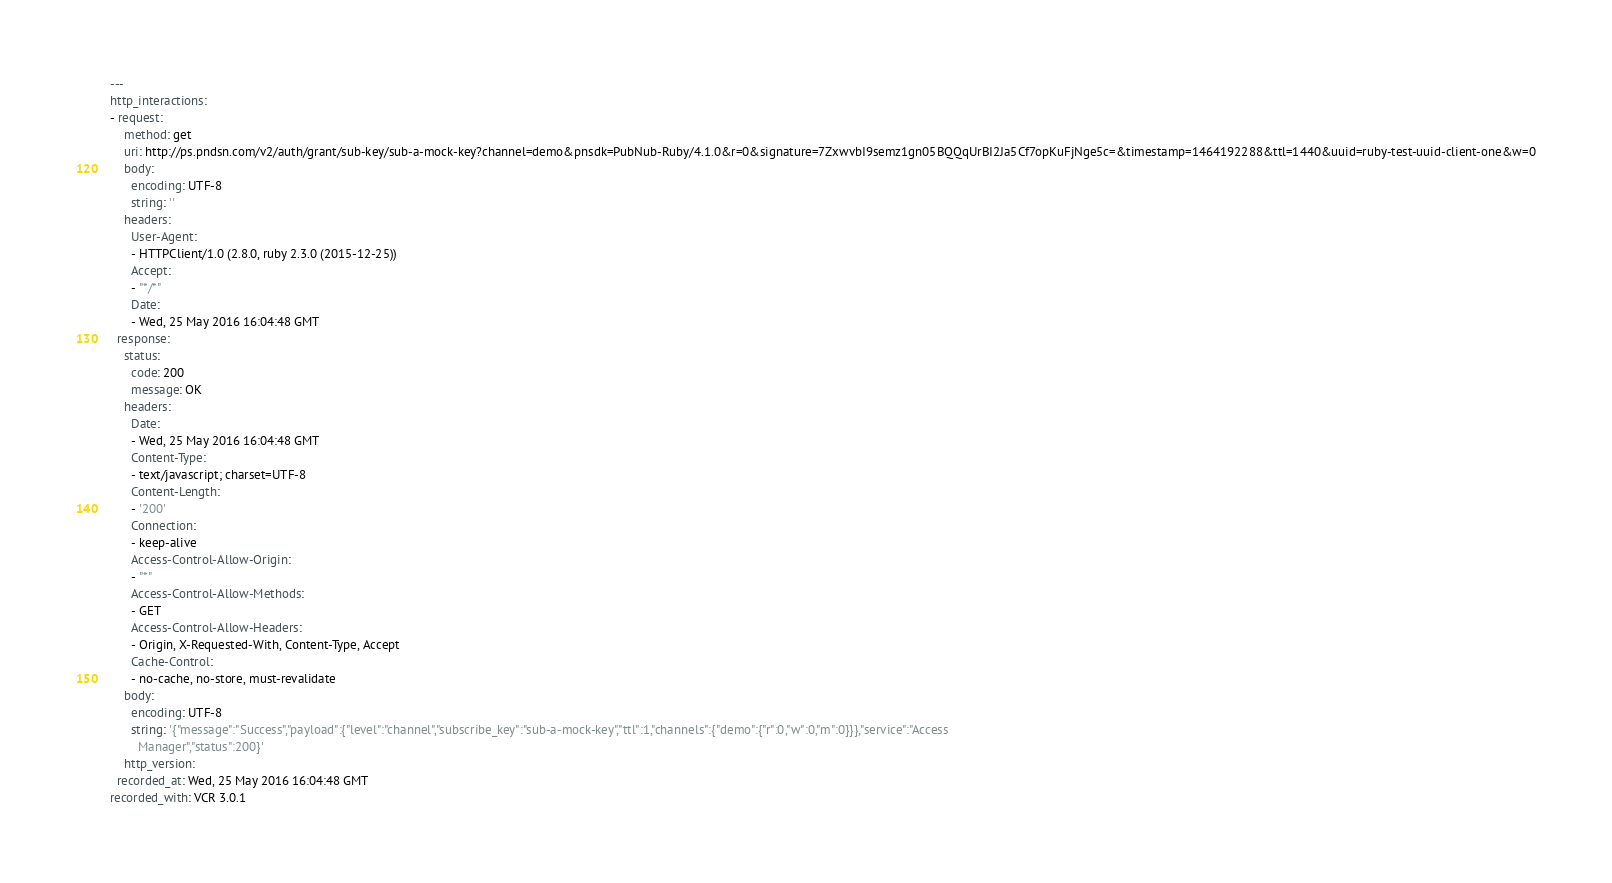Convert code to text. <code><loc_0><loc_0><loc_500><loc_500><_YAML_>---
http_interactions:
- request:
    method: get
    uri: http://ps.pndsn.com/v2/auth/grant/sub-key/sub-a-mock-key?channel=demo&pnsdk=PubNub-Ruby/4.1.0&r=0&signature=7ZxwvbI9semz1gn05BQQqUrBI2Ja5Cf7opKuFjNge5c=&timestamp=1464192288&ttl=1440&uuid=ruby-test-uuid-client-one&w=0
    body:
      encoding: UTF-8
      string: ''
    headers:
      User-Agent:
      - HTTPClient/1.0 (2.8.0, ruby 2.3.0 (2015-12-25))
      Accept:
      - "*/*"
      Date:
      - Wed, 25 May 2016 16:04:48 GMT
  response:
    status:
      code: 200
      message: OK
    headers:
      Date:
      - Wed, 25 May 2016 16:04:48 GMT
      Content-Type:
      - text/javascript; charset=UTF-8
      Content-Length:
      - '200'
      Connection:
      - keep-alive
      Access-Control-Allow-Origin:
      - "*"
      Access-Control-Allow-Methods:
      - GET
      Access-Control-Allow-Headers:
      - Origin, X-Requested-With, Content-Type, Accept
      Cache-Control:
      - no-cache, no-store, must-revalidate
    body:
      encoding: UTF-8
      string: '{"message":"Success","payload":{"level":"channel","subscribe_key":"sub-a-mock-key","ttl":1,"channels":{"demo":{"r":0,"w":0,"m":0}}},"service":"Access
        Manager","status":200}'
    http_version: 
  recorded_at: Wed, 25 May 2016 16:04:48 GMT
recorded_with: VCR 3.0.1
</code> 